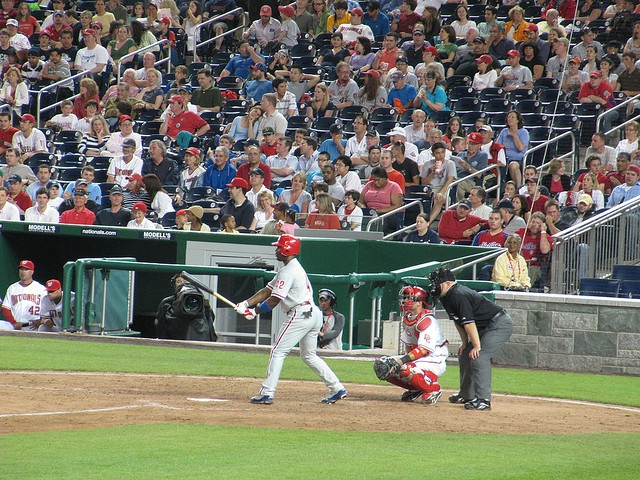Describe the objects in this image and their specific colors. I can see people in black, gray, and darkgray tones, chair in black, gray, darkgray, and navy tones, people in black, lightgray, darkgray, gray, and lightblue tones, people in black, gray, and darkgray tones, and people in black, white, gray, and maroon tones in this image. 